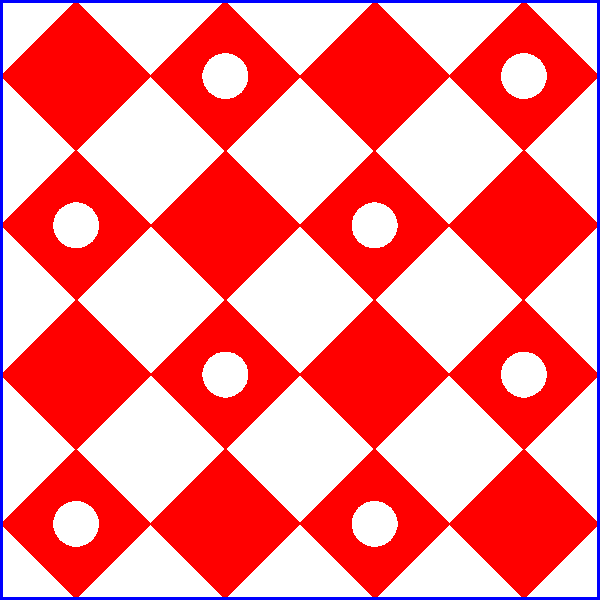In the geometric pattern above, inspired by traditional Mapuche textiles from Chile, what fraction of the diamond shapes contains a white circle? To determine the fraction of diamond shapes containing a white circle:

1. Count the total number of diamond shapes:
   - There are 4 rows and 4 columns of diamonds
   - Total diamonds = 4 × 4 = 16

2. Count the number of diamonds with white circles:
   - Circles appear in a checkerboard pattern
   - In each row, every other diamond has a circle
   - There are 2 circles in each of the 4 rows
   - Total circles = 2 × 4 = 8

3. Calculate the fraction:
   - Fraction = (Diamonds with circles) / (Total diamonds)
   - Fraction = 8 / 16 = 1 / 2

This pattern, representing balance and duality in Mapuche culture, shows exactly half of the diamonds containing circles.
Answer: $\frac{1}{2}$ 